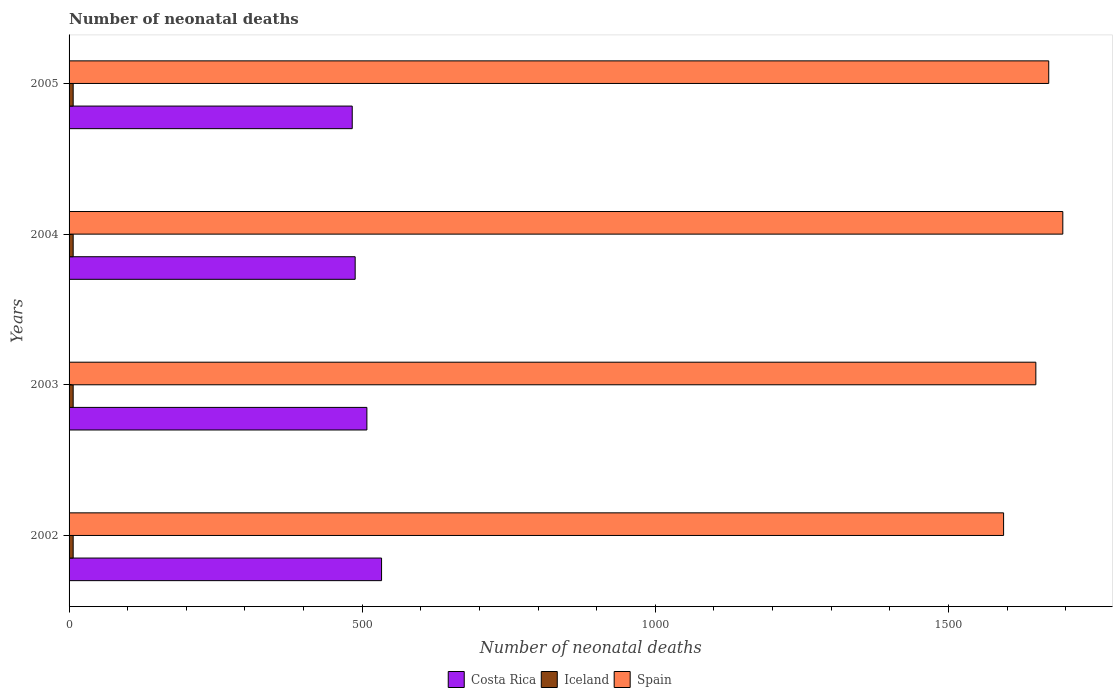How many groups of bars are there?
Offer a very short reply. 4. Are the number of bars per tick equal to the number of legend labels?
Offer a terse response. Yes. How many bars are there on the 3rd tick from the top?
Give a very brief answer. 3. How many bars are there on the 2nd tick from the bottom?
Give a very brief answer. 3. What is the label of the 1st group of bars from the top?
Keep it short and to the point. 2005. What is the number of neonatal deaths in in Costa Rica in 2002?
Offer a terse response. 533. Across all years, what is the maximum number of neonatal deaths in in Spain?
Provide a short and direct response. 1695. Across all years, what is the minimum number of neonatal deaths in in Iceland?
Offer a terse response. 7. In which year was the number of neonatal deaths in in Costa Rica maximum?
Give a very brief answer. 2002. In which year was the number of neonatal deaths in in Costa Rica minimum?
Your response must be concise. 2005. What is the total number of neonatal deaths in in Spain in the graph?
Your response must be concise. 6609. What is the difference between the number of neonatal deaths in in Costa Rica in 2002 and that in 2004?
Offer a very short reply. 45. What is the difference between the number of neonatal deaths in in Costa Rica in 2004 and the number of neonatal deaths in in Iceland in 2005?
Provide a short and direct response. 481. What is the average number of neonatal deaths in in Costa Rica per year?
Your answer should be very brief. 503. In the year 2002, what is the difference between the number of neonatal deaths in in Iceland and number of neonatal deaths in in Costa Rica?
Your answer should be compact. -526. What is the ratio of the number of neonatal deaths in in Costa Rica in 2002 to that in 2004?
Keep it short and to the point. 1.09. Is the number of neonatal deaths in in Costa Rica in 2003 less than that in 2005?
Give a very brief answer. No. Is the difference between the number of neonatal deaths in in Iceland in 2002 and 2003 greater than the difference between the number of neonatal deaths in in Costa Rica in 2002 and 2003?
Provide a short and direct response. No. What is the difference between the highest and the lowest number of neonatal deaths in in Spain?
Ensure brevity in your answer.  101. How many bars are there?
Provide a succinct answer. 12. Are all the bars in the graph horizontal?
Your answer should be compact. Yes. What is the difference between two consecutive major ticks on the X-axis?
Ensure brevity in your answer.  500. Does the graph contain any zero values?
Give a very brief answer. No. How many legend labels are there?
Your response must be concise. 3. How are the legend labels stacked?
Provide a short and direct response. Horizontal. What is the title of the graph?
Ensure brevity in your answer.  Number of neonatal deaths. Does "St. Kitts and Nevis" appear as one of the legend labels in the graph?
Offer a very short reply. No. What is the label or title of the X-axis?
Ensure brevity in your answer.  Number of neonatal deaths. What is the Number of neonatal deaths in Costa Rica in 2002?
Offer a terse response. 533. What is the Number of neonatal deaths of Spain in 2002?
Make the answer very short. 1594. What is the Number of neonatal deaths of Costa Rica in 2003?
Your response must be concise. 508. What is the Number of neonatal deaths of Iceland in 2003?
Offer a very short reply. 7. What is the Number of neonatal deaths of Spain in 2003?
Offer a terse response. 1649. What is the Number of neonatal deaths in Costa Rica in 2004?
Provide a short and direct response. 488. What is the Number of neonatal deaths in Iceland in 2004?
Ensure brevity in your answer.  7. What is the Number of neonatal deaths of Spain in 2004?
Ensure brevity in your answer.  1695. What is the Number of neonatal deaths of Costa Rica in 2005?
Provide a short and direct response. 483. What is the Number of neonatal deaths in Spain in 2005?
Give a very brief answer. 1671. Across all years, what is the maximum Number of neonatal deaths in Costa Rica?
Offer a very short reply. 533. Across all years, what is the maximum Number of neonatal deaths in Spain?
Offer a terse response. 1695. Across all years, what is the minimum Number of neonatal deaths in Costa Rica?
Give a very brief answer. 483. Across all years, what is the minimum Number of neonatal deaths of Spain?
Your answer should be very brief. 1594. What is the total Number of neonatal deaths in Costa Rica in the graph?
Your answer should be very brief. 2012. What is the total Number of neonatal deaths of Spain in the graph?
Your answer should be very brief. 6609. What is the difference between the Number of neonatal deaths of Iceland in 2002 and that in 2003?
Make the answer very short. 0. What is the difference between the Number of neonatal deaths of Spain in 2002 and that in 2003?
Make the answer very short. -55. What is the difference between the Number of neonatal deaths in Iceland in 2002 and that in 2004?
Provide a succinct answer. 0. What is the difference between the Number of neonatal deaths of Spain in 2002 and that in 2004?
Your response must be concise. -101. What is the difference between the Number of neonatal deaths of Costa Rica in 2002 and that in 2005?
Offer a very short reply. 50. What is the difference between the Number of neonatal deaths in Spain in 2002 and that in 2005?
Your response must be concise. -77. What is the difference between the Number of neonatal deaths of Costa Rica in 2003 and that in 2004?
Ensure brevity in your answer.  20. What is the difference between the Number of neonatal deaths in Spain in 2003 and that in 2004?
Your answer should be very brief. -46. What is the difference between the Number of neonatal deaths in Costa Rica in 2004 and that in 2005?
Your response must be concise. 5. What is the difference between the Number of neonatal deaths in Spain in 2004 and that in 2005?
Your answer should be compact. 24. What is the difference between the Number of neonatal deaths of Costa Rica in 2002 and the Number of neonatal deaths of Iceland in 2003?
Make the answer very short. 526. What is the difference between the Number of neonatal deaths of Costa Rica in 2002 and the Number of neonatal deaths of Spain in 2003?
Your answer should be very brief. -1116. What is the difference between the Number of neonatal deaths in Iceland in 2002 and the Number of neonatal deaths in Spain in 2003?
Keep it short and to the point. -1642. What is the difference between the Number of neonatal deaths in Costa Rica in 2002 and the Number of neonatal deaths in Iceland in 2004?
Your answer should be compact. 526. What is the difference between the Number of neonatal deaths of Costa Rica in 2002 and the Number of neonatal deaths of Spain in 2004?
Make the answer very short. -1162. What is the difference between the Number of neonatal deaths in Iceland in 2002 and the Number of neonatal deaths in Spain in 2004?
Keep it short and to the point. -1688. What is the difference between the Number of neonatal deaths in Costa Rica in 2002 and the Number of neonatal deaths in Iceland in 2005?
Your answer should be very brief. 526. What is the difference between the Number of neonatal deaths in Costa Rica in 2002 and the Number of neonatal deaths in Spain in 2005?
Offer a terse response. -1138. What is the difference between the Number of neonatal deaths of Iceland in 2002 and the Number of neonatal deaths of Spain in 2005?
Give a very brief answer. -1664. What is the difference between the Number of neonatal deaths of Costa Rica in 2003 and the Number of neonatal deaths of Iceland in 2004?
Keep it short and to the point. 501. What is the difference between the Number of neonatal deaths of Costa Rica in 2003 and the Number of neonatal deaths of Spain in 2004?
Your response must be concise. -1187. What is the difference between the Number of neonatal deaths in Iceland in 2003 and the Number of neonatal deaths in Spain in 2004?
Give a very brief answer. -1688. What is the difference between the Number of neonatal deaths of Costa Rica in 2003 and the Number of neonatal deaths of Iceland in 2005?
Keep it short and to the point. 501. What is the difference between the Number of neonatal deaths in Costa Rica in 2003 and the Number of neonatal deaths in Spain in 2005?
Your answer should be very brief. -1163. What is the difference between the Number of neonatal deaths in Iceland in 2003 and the Number of neonatal deaths in Spain in 2005?
Offer a very short reply. -1664. What is the difference between the Number of neonatal deaths in Costa Rica in 2004 and the Number of neonatal deaths in Iceland in 2005?
Your response must be concise. 481. What is the difference between the Number of neonatal deaths of Costa Rica in 2004 and the Number of neonatal deaths of Spain in 2005?
Provide a succinct answer. -1183. What is the difference between the Number of neonatal deaths in Iceland in 2004 and the Number of neonatal deaths in Spain in 2005?
Provide a succinct answer. -1664. What is the average Number of neonatal deaths of Costa Rica per year?
Make the answer very short. 503. What is the average Number of neonatal deaths of Iceland per year?
Keep it short and to the point. 7. What is the average Number of neonatal deaths of Spain per year?
Your response must be concise. 1652.25. In the year 2002, what is the difference between the Number of neonatal deaths in Costa Rica and Number of neonatal deaths in Iceland?
Offer a terse response. 526. In the year 2002, what is the difference between the Number of neonatal deaths in Costa Rica and Number of neonatal deaths in Spain?
Give a very brief answer. -1061. In the year 2002, what is the difference between the Number of neonatal deaths in Iceland and Number of neonatal deaths in Spain?
Provide a succinct answer. -1587. In the year 2003, what is the difference between the Number of neonatal deaths in Costa Rica and Number of neonatal deaths in Iceland?
Keep it short and to the point. 501. In the year 2003, what is the difference between the Number of neonatal deaths in Costa Rica and Number of neonatal deaths in Spain?
Provide a succinct answer. -1141. In the year 2003, what is the difference between the Number of neonatal deaths in Iceland and Number of neonatal deaths in Spain?
Give a very brief answer. -1642. In the year 2004, what is the difference between the Number of neonatal deaths in Costa Rica and Number of neonatal deaths in Iceland?
Your answer should be very brief. 481. In the year 2004, what is the difference between the Number of neonatal deaths of Costa Rica and Number of neonatal deaths of Spain?
Your response must be concise. -1207. In the year 2004, what is the difference between the Number of neonatal deaths of Iceland and Number of neonatal deaths of Spain?
Provide a succinct answer. -1688. In the year 2005, what is the difference between the Number of neonatal deaths of Costa Rica and Number of neonatal deaths of Iceland?
Give a very brief answer. 476. In the year 2005, what is the difference between the Number of neonatal deaths in Costa Rica and Number of neonatal deaths in Spain?
Offer a terse response. -1188. In the year 2005, what is the difference between the Number of neonatal deaths of Iceland and Number of neonatal deaths of Spain?
Keep it short and to the point. -1664. What is the ratio of the Number of neonatal deaths in Costa Rica in 2002 to that in 2003?
Keep it short and to the point. 1.05. What is the ratio of the Number of neonatal deaths in Spain in 2002 to that in 2003?
Ensure brevity in your answer.  0.97. What is the ratio of the Number of neonatal deaths in Costa Rica in 2002 to that in 2004?
Your answer should be very brief. 1.09. What is the ratio of the Number of neonatal deaths of Iceland in 2002 to that in 2004?
Your response must be concise. 1. What is the ratio of the Number of neonatal deaths in Spain in 2002 to that in 2004?
Make the answer very short. 0.94. What is the ratio of the Number of neonatal deaths of Costa Rica in 2002 to that in 2005?
Ensure brevity in your answer.  1.1. What is the ratio of the Number of neonatal deaths in Iceland in 2002 to that in 2005?
Provide a short and direct response. 1. What is the ratio of the Number of neonatal deaths of Spain in 2002 to that in 2005?
Your answer should be compact. 0.95. What is the ratio of the Number of neonatal deaths of Costa Rica in 2003 to that in 2004?
Offer a very short reply. 1.04. What is the ratio of the Number of neonatal deaths in Spain in 2003 to that in 2004?
Your response must be concise. 0.97. What is the ratio of the Number of neonatal deaths in Costa Rica in 2003 to that in 2005?
Give a very brief answer. 1.05. What is the ratio of the Number of neonatal deaths in Iceland in 2003 to that in 2005?
Offer a terse response. 1. What is the ratio of the Number of neonatal deaths of Spain in 2003 to that in 2005?
Offer a very short reply. 0.99. What is the ratio of the Number of neonatal deaths in Costa Rica in 2004 to that in 2005?
Offer a very short reply. 1.01. What is the ratio of the Number of neonatal deaths in Iceland in 2004 to that in 2005?
Provide a short and direct response. 1. What is the ratio of the Number of neonatal deaths of Spain in 2004 to that in 2005?
Offer a terse response. 1.01. What is the difference between the highest and the second highest Number of neonatal deaths in Costa Rica?
Your answer should be compact. 25. What is the difference between the highest and the lowest Number of neonatal deaths of Iceland?
Your response must be concise. 0. What is the difference between the highest and the lowest Number of neonatal deaths in Spain?
Offer a very short reply. 101. 